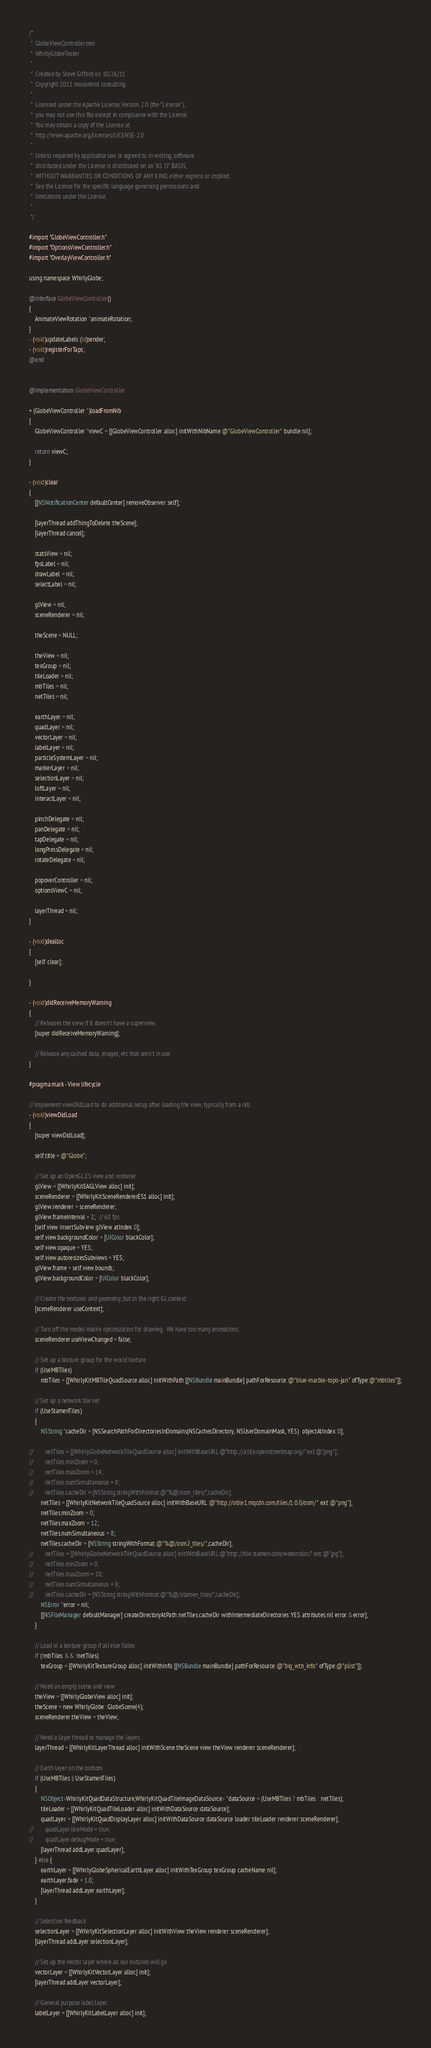<code> <loc_0><loc_0><loc_500><loc_500><_ObjectiveC_>/*
 *  GlobeViewController.mm
 *  WhirlyGlobeTester
 *
 *  Created by Steve Gifford on 10/26/11.
 *  Copyright 2011 mousebird consulting
 *
 *  Licensed under the Apache License, Version 2.0 (the "License");
 *  you may not use this file except in compliance with the License.
 *  You may obtain a copy of the License at
 *  http://www.apache.org/licenses/LICENSE-2.0
 *
 *  Unless required by applicable law or agreed to in writing, software
 *  distributed under the License is distributed on an "AS IS" BASIS,
 *  WITHOUT WARRANTIES OR CONDITIONS OF ANY KIND, either express or implied.
 *  See the License for the specific language governing permissions and
 *  limitations under the License.
 *
 */

#import "GlobeViewController.h"
#import "OptionsViewController.h"
#import "OverlayViewController.h"

using namespace WhirlyGlobe;

@interface GlobeViewController()
{
    AnimateViewRotation *animateRotation;
}
- (void)updateLabels:(id)sender;
- (void)registerForTaps;
@end


@implementation GlobeViewController

+ (GlobeViewController *)loadFromNib
{
    GlobeViewController *viewC = [[GlobeViewController alloc] initWithNibName:@"GlobeViewController" bundle:nil];
    
    return viewC;
}

- (void)clear
{
    [[NSNotificationCenter defaultCenter] removeObserver:self];
        
    [layerThread addThingToDelete:theScene];
    [layerThread cancel];
    
    statsView = nil;
    fpsLabel = nil;
    drawLabel = nil;
    selectLabel = nil;
    
    glView = nil;
    sceneRenderer = nil;

    theScene = NULL;
    
    theView = nil;
    texGroup = nil;
    tileLoader = nil;
    mbTiles = nil;
    netTiles = nil;
    
    earthLayer = nil;
    quadLayer = nil;
    vectorLayer = nil;
    labelLayer = nil;
    particleSystemLayer = nil;
    markerLayer = nil;
    selectionLayer = nil;
    loftLayer = nil;
    interactLayer = nil;
    
    pinchDelegate = nil;
    panDelegate = nil;
    tapDelegate = nil;
    longPressDelegate = nil;
    rotateDelegate = nil;
    
    popoverController = nil;
    optionsViewC = nil;

    layerThread = nil;
}

- (void)dealloc
{
    [self clear];
    
}

- (void)didReceiveMemoryWarning
{
    // Releases the view if it doesn't have a superview.
    [super didReceiveMemoryWarning];
    
    // Release any cached data, images, etc that aren't in use.
}

#pragma mark - View lifecycle

// Implement viewDidLoad to do additional setup after loading the view, typically from a nib.
- (void)viewDidLoad
{
    [super viewDidLoad];
    
    self.title = @"Globe";
    
	// Set up an OpenGL ES view and renderer
	glView = [[WhirlyKitEAGLView alloc] init];
	sceneRenderer = [[WhirlyKitSceneRendererES1 alloc] init];
	glView.renderer = sceneRenderer;
	glView.frameInterval = 2;  // 60 fps
    [self.view insertSubview:glView atIndex:0];
    self.view.backgroundColor = [UIColor blackColor];
    self.view.opaque = YES;
	self.view.autoresizesSubviews = YES;
	glView.frame = self.view.bounds;
    glView.backgroundColor = [UIColor blackColor];
    
	// Create the textures and geometry, but in the right GL context
	[sceneRenderer useContext];
    
    // Turn off the model matrix optimization for drawing.  We have too many animations.
    sceneRenderer.useViewChanged = false;
	
	// Set up a texture group for the world texture
    if (UseMBTiles)
        mbTiles = [[WhirlyKitMBTileQuadSource alloc] initWithPath:[[NSBundle mainBundle] pathForResource:@"blue-marble-topo-jan" ofType:@"mbtiles"]];
    
    // Set up a network tile set
    if (UseStamenTiles)
    {
        NSString *cacheDir = [NSSearchPathForDirectoriesInDomains(NSCachesDirectory, NSUserDomainMask, YES)  objectAtIndex:0];

//        netTiles = [[WhirlyGlobeNetworkTileQuadSource alloc] initWithBaseURL:@"http://a.tile.openstreetmap.org/" ext:@"png"];
//        netTiles.minZoom = 0;
//        netTiles.maxZoom = 14;
//        netTiles.numSimultaneous = 8;
//        netTiles.cacheDir = [NSString stringWithFormat:@"%@/osm_tiles/",cacheDir];
        netTiles = [[WhirlyKitNetworkTileQuadSource alloc] initWithBaseURL:@"http://otile1.mqcdn.com/tiles/1.0.0/osm/" ext:@"png"];
        netTiles.minZoom = 0;
        netTiles.maxZoom = 12;
        netTiles.numSimultaneous = 8;
        netTiles.cacheDir = [NSString stringWithFormat:@"%@/osm2_tiles/",cacheDir];        
//        netTiles = [[WhirlyGlobeNetworkTileQuadSource alloc] initWithBaseURL:@"http://tile.stamen.com/watercolor/" ext:@"jpg"];
//        netTiles.minZoom = 0;
//        netTiles.maxZoom = 10;
//        netTiles.numSimultaneous = 8;
//        netTiles.cacheDir = [NSString stringWithFormat:@"%@/stamen_tiles/",cacheDir];
        NSError *error = nil;
        [[NSFileManager defaultManager] createDirectoryAtPath:netTiles.cacheDir withIntermediateDirectories:YES attributes:nil error:&error];
    }

    // Load in a texture group if all else failes
    if (!mbTiles && !netTiles)
        texGroup = [[WhirlyKitTextureGroup alloc] initWithInfo:[[NSBundle mainBundle] pathForResource:@"big_wtb_info" ofType:@"plist"]];
    
	// Need an empty scene and view    
	theView = [[WhirlyGlobeView alloc] init];
    theScene = new WhirlyGlobe::GlobeScene(4);
    sceneRenderer.theView = theView;
	
	// Need a layer thread to manage the layers
	layerThread = [[WhirlyKitLayerThread alloc] initWithScene:theScene view:theView renderer:sceneRenderer];
	
	// Earth layer on the bottom
    if (UseMBTiles || UseStamenTiles)
    {
        NSObject<WhirlyKitQuadDataStructure,WhirlyKitQuadTileImageDataSource> *dataSource = (UseMBTiles ? mbTiles : netTiles);
        tileLoader = [[WhirlyKitQuadTileLoader alloc] initWithDataSource:dataSource];
        quadLayer = [[WhirlyKitQuadDisplayLayer alloc] initWithDataSource:dataSource loader:tileLoader renderer:sceneRenderer];
//        quadLayer.lineMode = true;
//        quadLayer.debugMode = true;
        [layerThread addLayer:quadLayer];
    } else {
        earthLayer = [[WhirlyGlobeSphericalEarthLayer alloc] initWithTexGroup:texGroup cacheName:nil];
        earthLayer.fade = 1.0;
        [layerThread addLayer:earthLayer];
    }
    
    // Selection feedback
    selectionLayer = [[WhirlyKitSelectionLayer alloc] initWithView:theView renderer:sceneRenderer];
    [layerThread addLayer:selectionLayer];

	// Set up the vector layer where all our outlines will go
	vectorLayer = [[WhirlyKitVectorLayer alloc] init];
	[layerThread addLayer:vectorLayer];
    
	// General purpose label layer.
	labelLayer = [[WhirlyKitLabelLayer alloc] init];</code> 